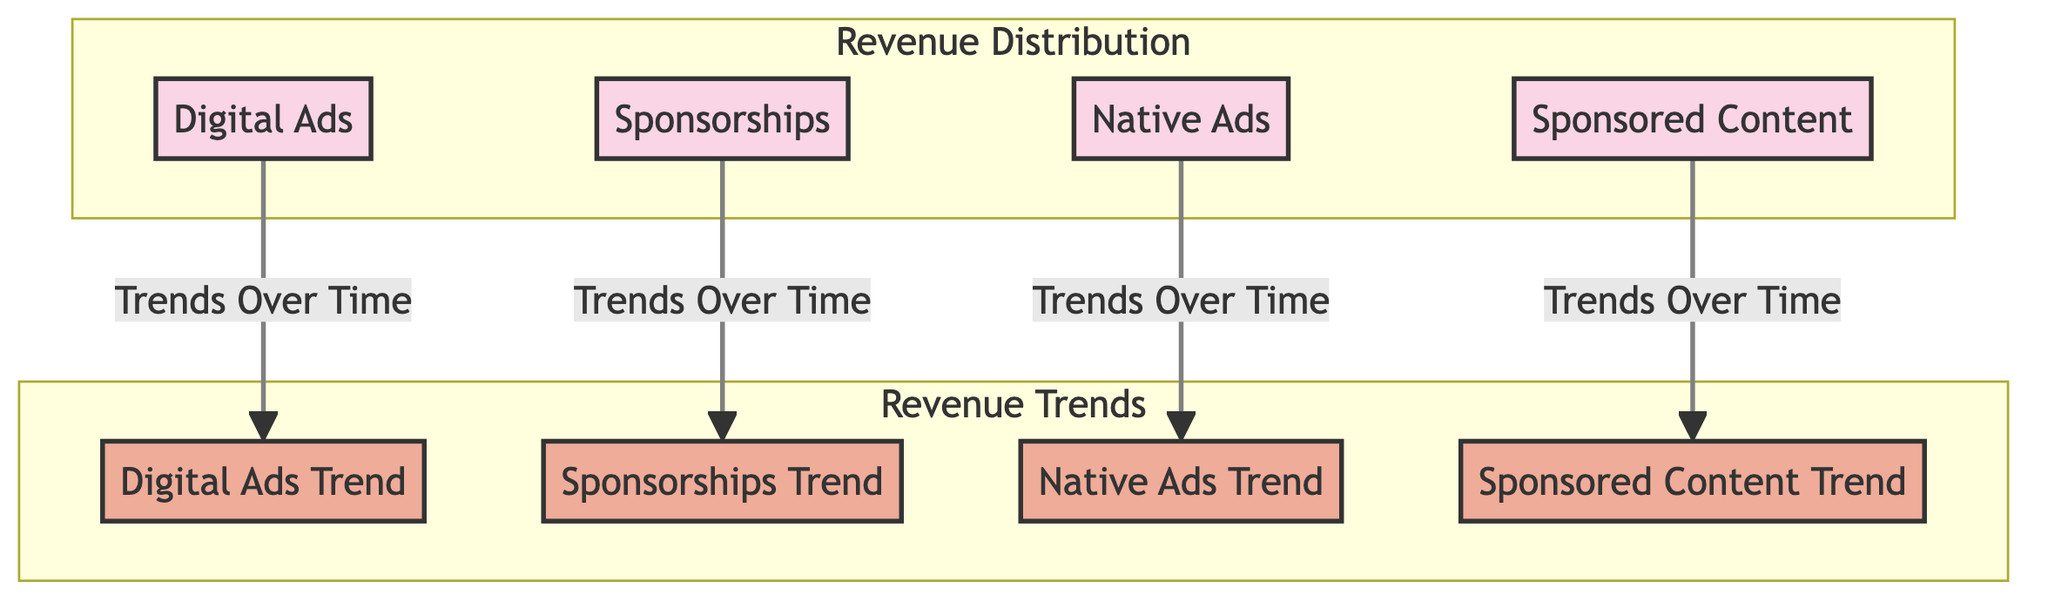What are the main advertising channels represented in the diagram? The diagram includes four main advertising channels represented as pie charts: Digital Ads, Sponsorships, Native Ads, and Sponsored Content.
Answer: Digital Ads, Sponsorships, Native Ads, Sponsored Content How many pie charts are there in the Revenue Distribution section? The Revenue Distribution section contains four pie charts, each representing a different advertising channel.
Answer: Four Which advertising channel shows the highest trend over time? To determine the highest trend over time, one would compare the bar graphs representing trends for each advertising channel. The graph with the tallest bar would indicate the channel with the highest trend.
Answer: (Requires visual comparison from the diagram) What type of data visualizations are used for Revenue Distribution? The Revenue Distribution section uses pie charts to visualize how revenue is apportioned across different advertising channels.
Answer: Pie charts What is the relationship between Digital Ads and its trend over time? The diagram illustrates a direct connection from the Digital Ads pie chart to its corresponding trend bar graph, indicating that the trend represents the performance or revenue evolution of Digital Ads.
Answer: Direct connection Which advertising channel has the least representation in the Revenue Distribution? This question requires a comparison of the pie charts to discern which channel has the smallest section and therefore the least representation in the revenue distribution.
Answer: (Requires visual comparison from the diagram) How do the trends for Sponsorships and Sponsored Content compare? To compare these two, one must analyze the heights of the corresponding bar graphs for Sponsorships Trend and Sponsored Content Trend; the one with the higher bar represents better trend performance over time.
Answer: (Requires visual comparison from the diagram) What color is used for the bar graphs in the Revenue Trends section? The bar graphs in the Revenue Trends section are colored in a shade designated by the class definition in the code, which is a specific color (eeac99).
Answer: (Requires visual color identification from the diagram) 